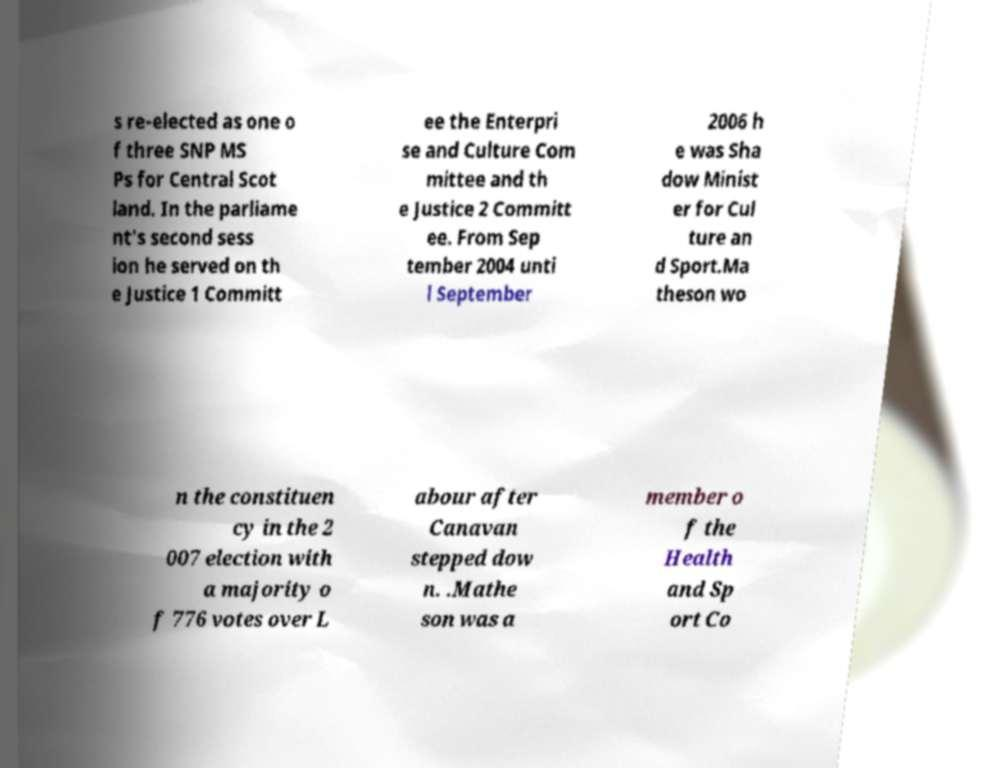Can you read and provide the text displayed in the image?This photo seems to have some interesting text. Can you extract and type it out for me? s re-elected as one o f three SNP MS Ps for Central Scot land. In the parliame nt's second sess ion he served on th e Justice 1 Committ ee the Enterpri se and Culture Com mittee and th e Justice 2 Committ ee. From Sep tember 2004 unti l September 2006 h e was Sha dow Minist er for Cul ture an d Sport.Ma theson wo n the constituen cy in the 2 007 election with a majority o f 776 votes over L abour after Canavan stepped dow n. .Mathe son was a member o f the Health and Sp ort Co 